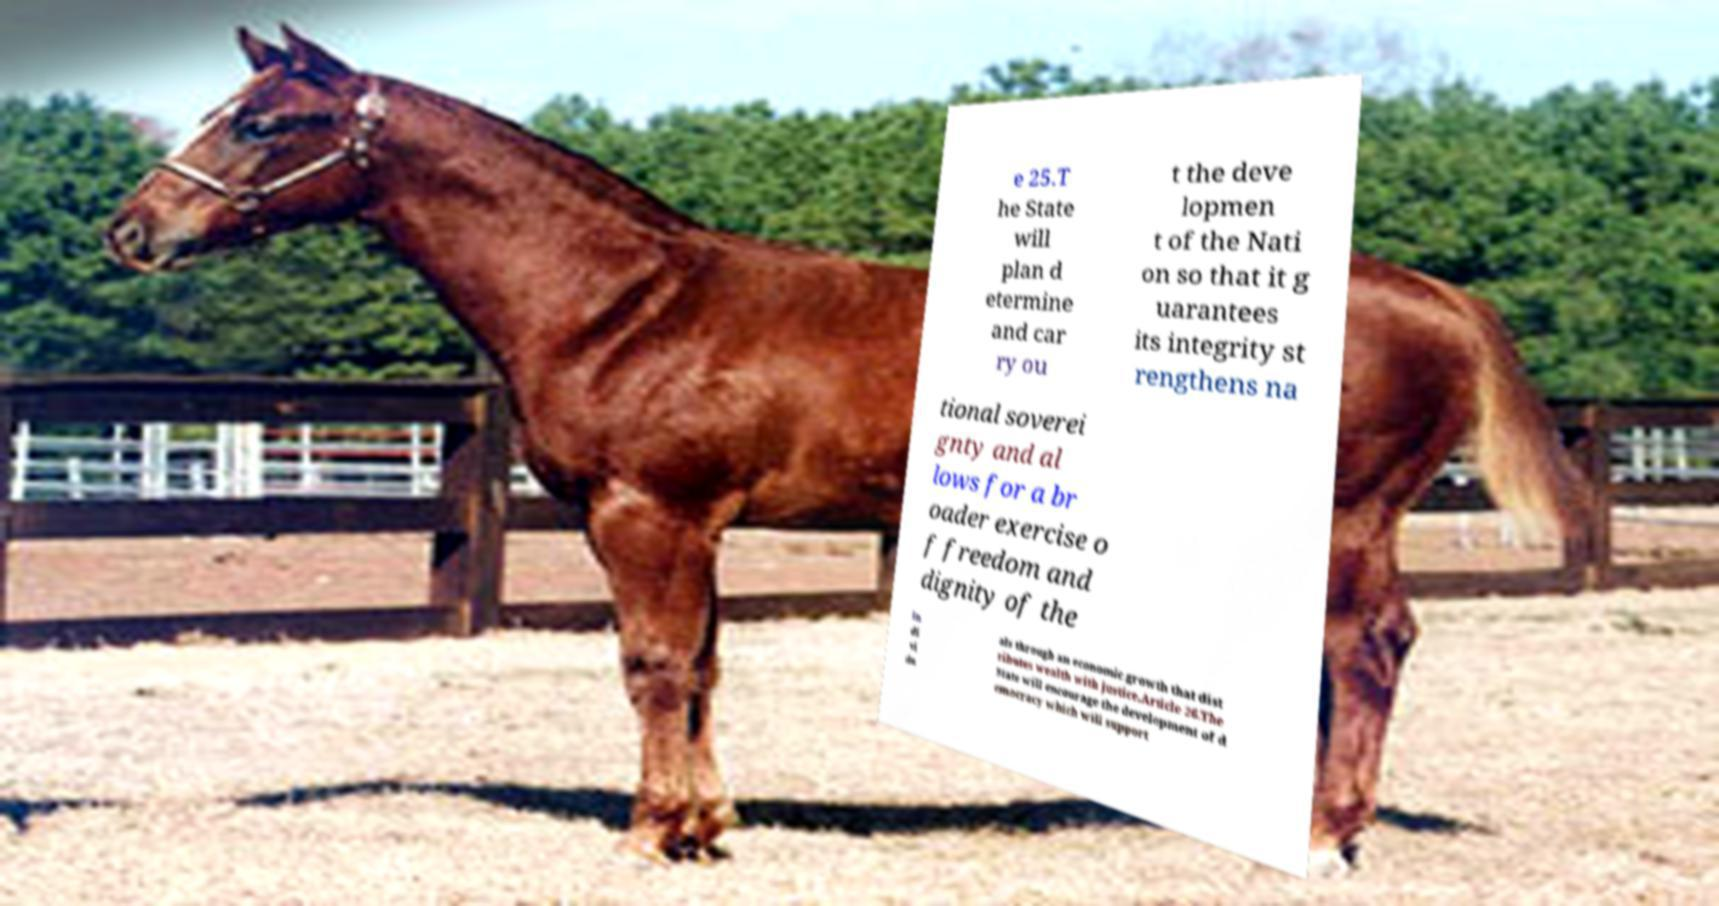Please identify and transcribe the text found in this image. e 25.T he State will plan d etermine and car ry ou t the deve lopmen t of the Nati on so that it g uarantees its integrity st rengthens na tional soverei gnty and al lows for a br oader exercise o f freedom and dignity of the in di vi du als through an economic growth that dist ributes wealth with justice.Article 26.The State will encourage the development of d emocracy which will support 